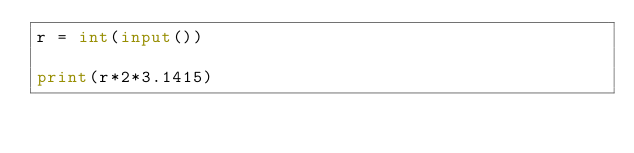Convert code to text. <code><loc_0><loc_0><loc_500><loc_500><_Python_>r = int(input())

print(r*2*3.1415)</code> 